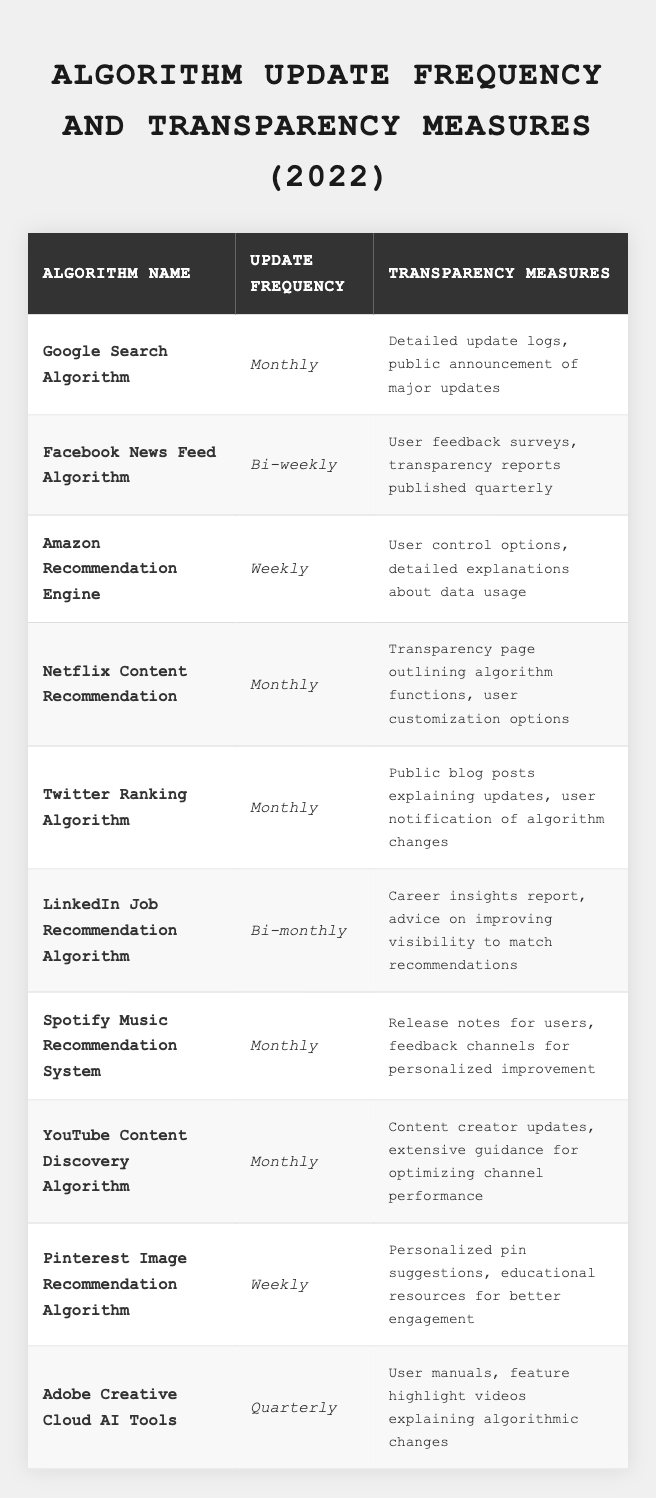What is the update frequency of the Google Search Algorithm? The table clearly lists the update frequency for each algorithm. For the Google Search Algorithm, it states "Monthly."
Answer: Monthly How many algorithms have a weekly update frequency? By reviewing the table, I can see that the Amazon Recommendation Engine and Pinterest Image Recommendation Algorithm are both listed with a "Weekly" update frequency, so there are two such algorithms.
Answer: 2 Does the Spotify Music Recommendation System have transparency measures? The table details the transparency measures for each algorithm. For the Spotify Music Recommendation System, it mentions "Release notes for users, feedback channels for personalized improvement," confirming that it has transparency measures.
Answer: Yes Which algorithm has the least frequent updates? Looking at the update frequencies, the Adobe Creative Cloud AI Tools is updated "Quarterly," which is less frequent than all the other algorithms listed.
Answer: Adobe Creative Cloud AI Tools What are the transparency measures for the Facebook News Feed Algorithm? The table provides specific transparency measures for each algorithm. For the Facebook News Feed Algorithm, it states "User feedback surveys, transparency reports published quarterly."
Answer: User feedback surveys, transparency reports published quarterly Which algorithms are updated monthly and have user feedback options in their transparency measures? Reviewing the table, the monthly updated algorithms include Google Search Algorithm, Netflix Content Recommendation, Twitter Ranking Algorithm, Spotify Music Recommendation System, and YouTube Content Discovery Algorithm. Among these, the Spotify Music Recommendation System includes "feedback channels for personalized improvement" in its transparency measures. Therefore, the only algorithm meeting both criteria is the Spotify Music Recommendation System.
Answer: Spotify Music Recommendation System How many algorithms are updated bi-monthly or less frequently? The algorithms that are updated bi-monthly or less frequently include the Facebook News Feed Algorithm (Bi-weekly), LinkedIn Job Recommendation Algorithm (Bi-monthly), and Adobe Creative Cloud AI Tools (Quarterly). Counting these, this gives a total of three algorithms.
Answer: 3 Is it true that all algorithms published transparency reports? Not all listed algorithms have transparency reports. Specifically, the Adobe Creative Cloud AI Tools do not mention transparency reports among their measures, so the statement is false.
Answer: No Which algorithm utilizes user control options in its transparency measures? The Amazon Recommendation Engine is specifically noted in the table as having "User control options" included in its transparency measures, indicating it allows users some level of control.
Answer: Amazon Recommendation Engine How does the update frequency of the LinkedIn Job Recommendation Algorithm compare to the Facebook News Feed Algorithm? The LinkedIn Job Recommendation Algorithm updates bi-monthly, while the Facebook News Feed Algorithm updates bi-weekly. This means the LinkedIn Job Recommendation Algorithm updates less frequently than the Facebook News Feed Algorithm.
Answer: LinkedIn updates less frequently 